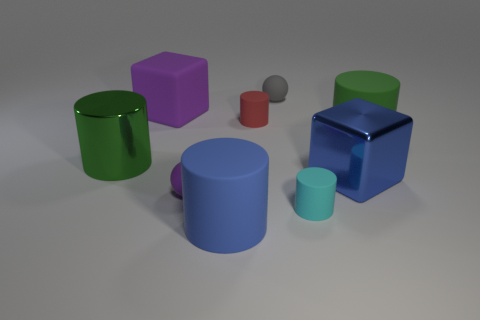Add 1 blue blocks. How many objects exist? 10 Subtract all big rubber cylinders. How many cylinders are left? 3 Subtract all brown spheres. How many green cylinders are left? 2 Subtract all gray balls. How many balls are left? 1 Subtract all blocks. How many objects are left? 7 Subtract all purple spheres. Subtract all brown blocks. How many spheres are left? 1 Subtract all large objects. Subtract all purple metallic things. How many objects are left? 4 Add 8 big green metallic things. How many big green metallic things are left? 9 Add 9 big purple metal cylinders. How many big purple metal cylinders exist? 9 Subtract 1 cyan cylinders. How many objects are left? 8 